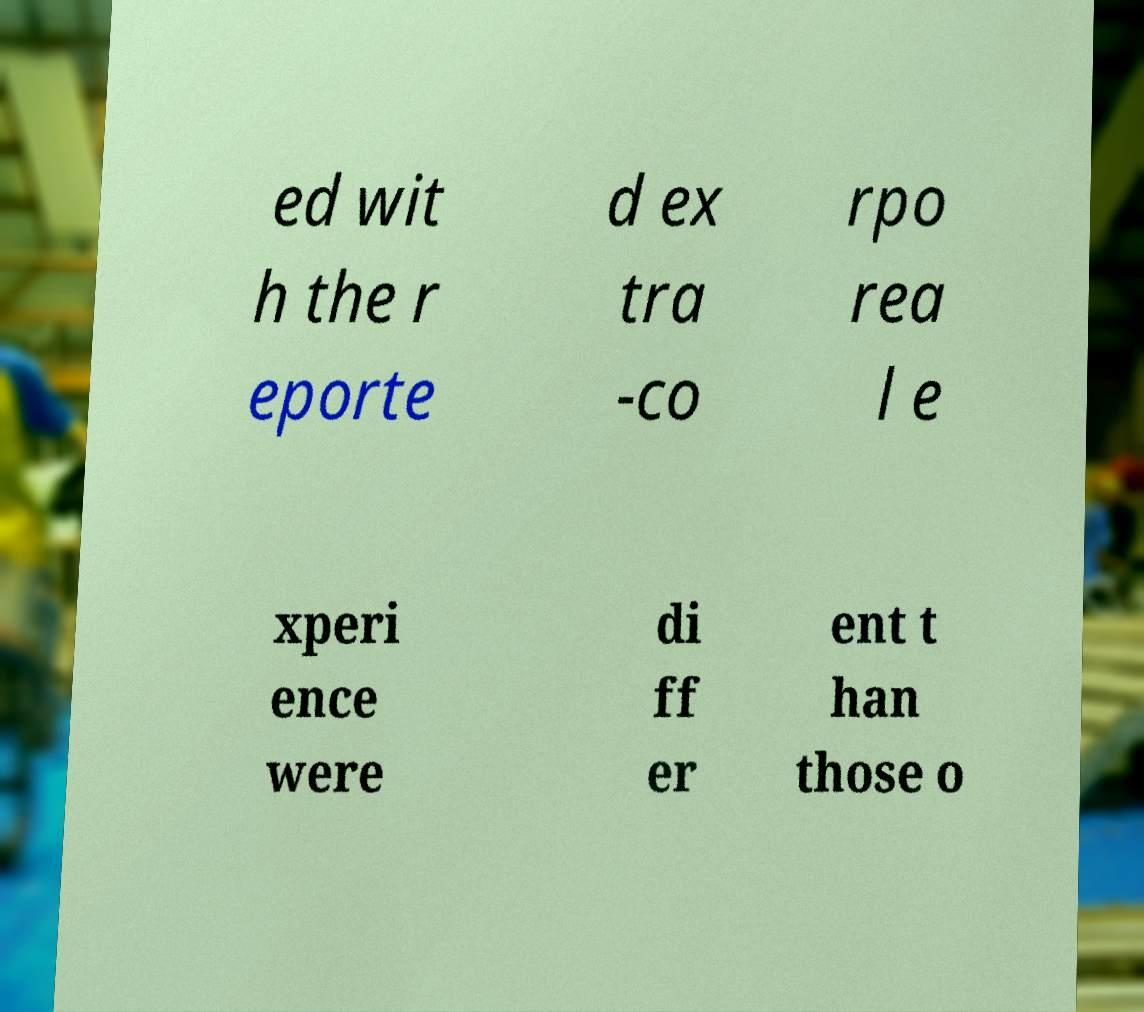What messages or text are displayed in this image? I need them in a readable, typed format. ed wit h the r eporte d ex tra -co rpo rea l e xperi ence were di ff er ent t han those o 